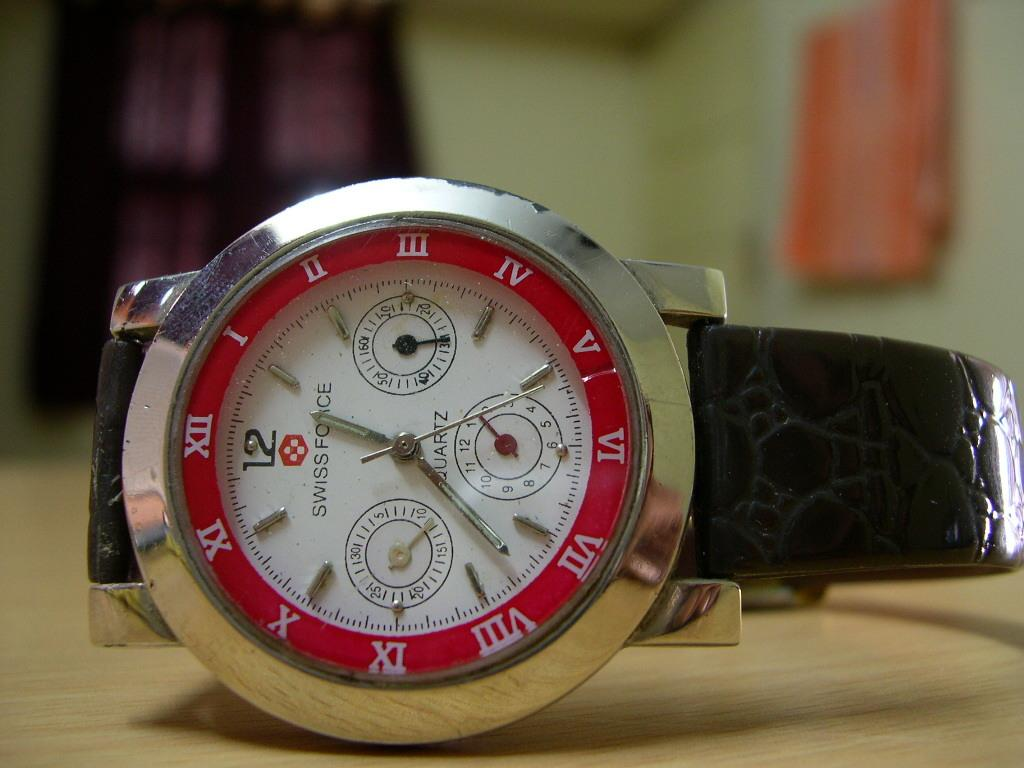Provide a one-sentence caption for the provided image. A Swiss Force Quartz watch placed on a wooden surface. 